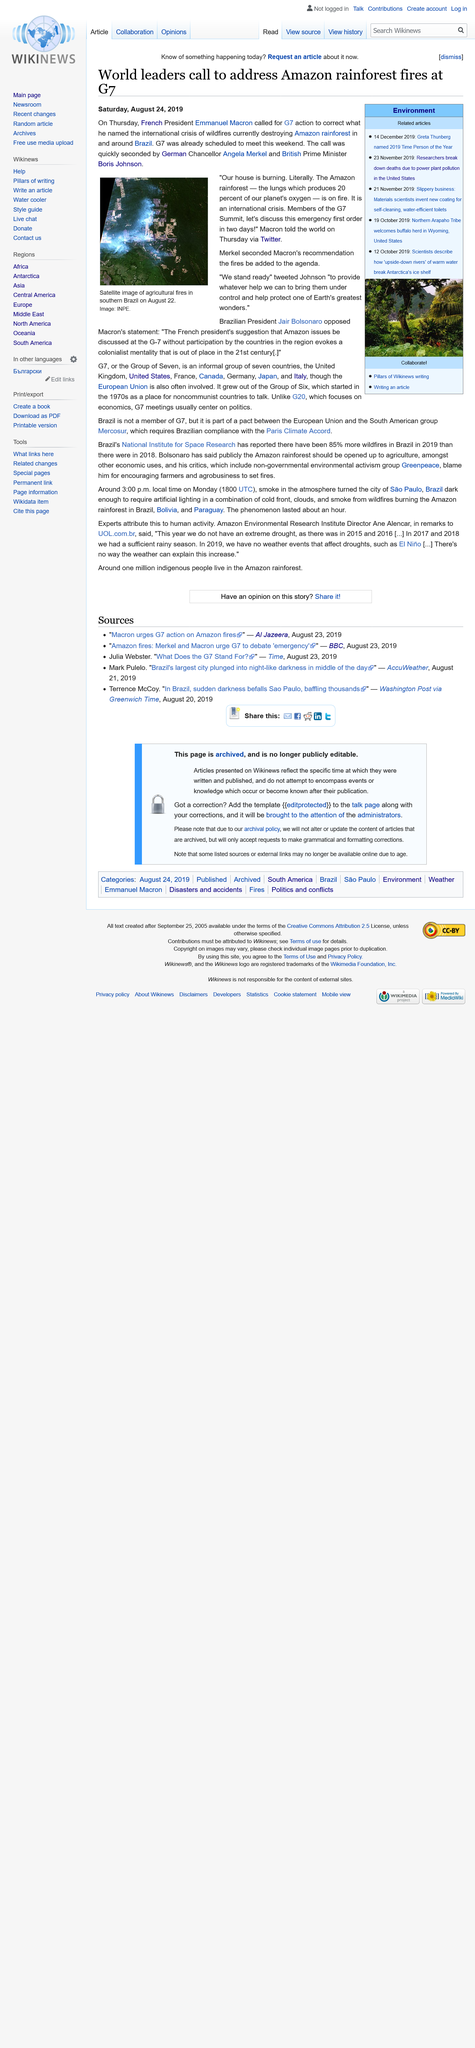Identify some key points in this picture. The Amazon rainforest produces 20% of the oxygen that our planet needs. The agricultural fires in the Amazon rainforest in southern Brazil were expected to be a key topic of discussion at the 2019 G7 Summit. The individual known as Greta Thunberg was selected as the 2019 Time Person of the Year. 